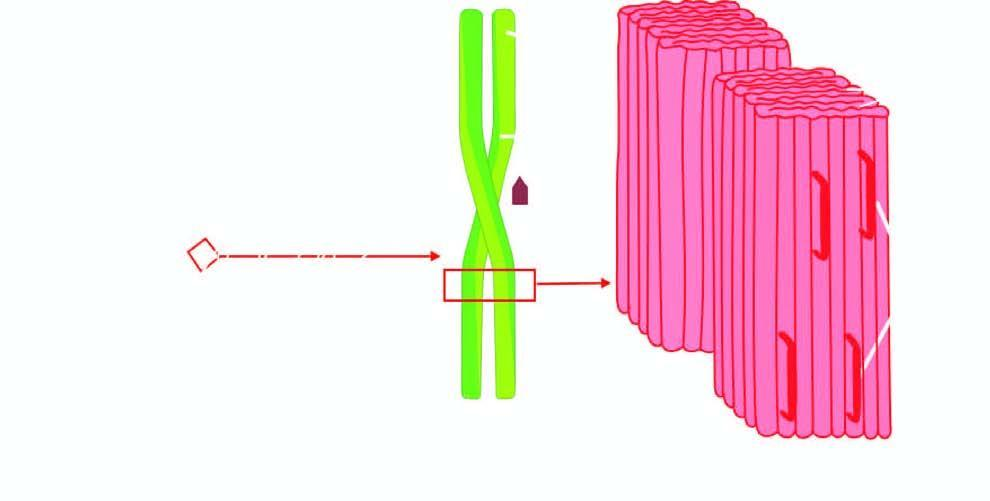what is further composed of double helix of two pleated sheets in the form of twin filaments separated by a clear space?
Answer the question using a single word or phrase. Each fibril 